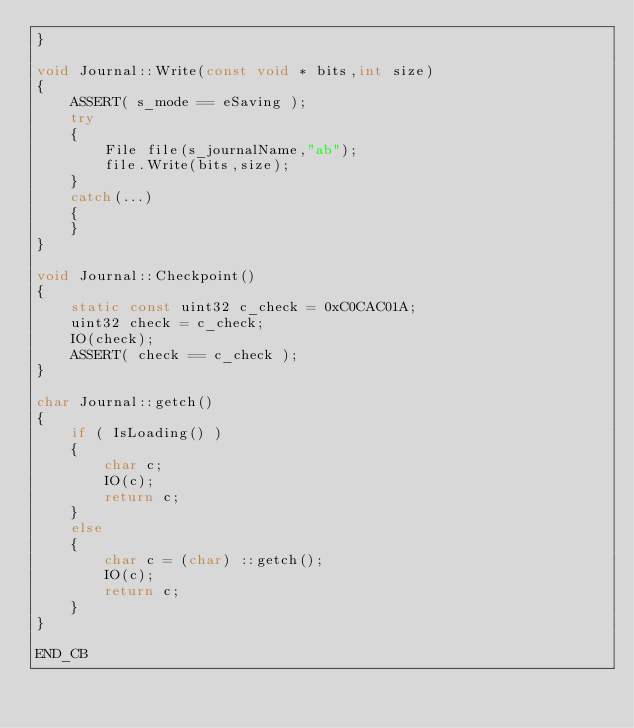<code> <loc_0><loc_0><loc_500><loc_500><_C++_>}

void Journal::Write(const void * bits,int size)
{
	ASSERT( s_mode == eSaving );
	try
	{
		File file(s_journalName,"ab");
		file.Write(bits,size);
	}
	catch(...)
	{
	}
}

void Journal::Checkpoint()
{
	static const uint32 c_check = 0xC0CAC01A;
	uint32 check = c_check;
	IO(check);
	ASSERT( check == c_check );
}

char Journal::getch()
{
	if ( IsLoading() )
	{
		char c;
		IO(c);
		return c;
	}
	else
	{
		char c = (char) ::getch();
		IO(c);
		return c;
	}
}

END_CB
</code> 